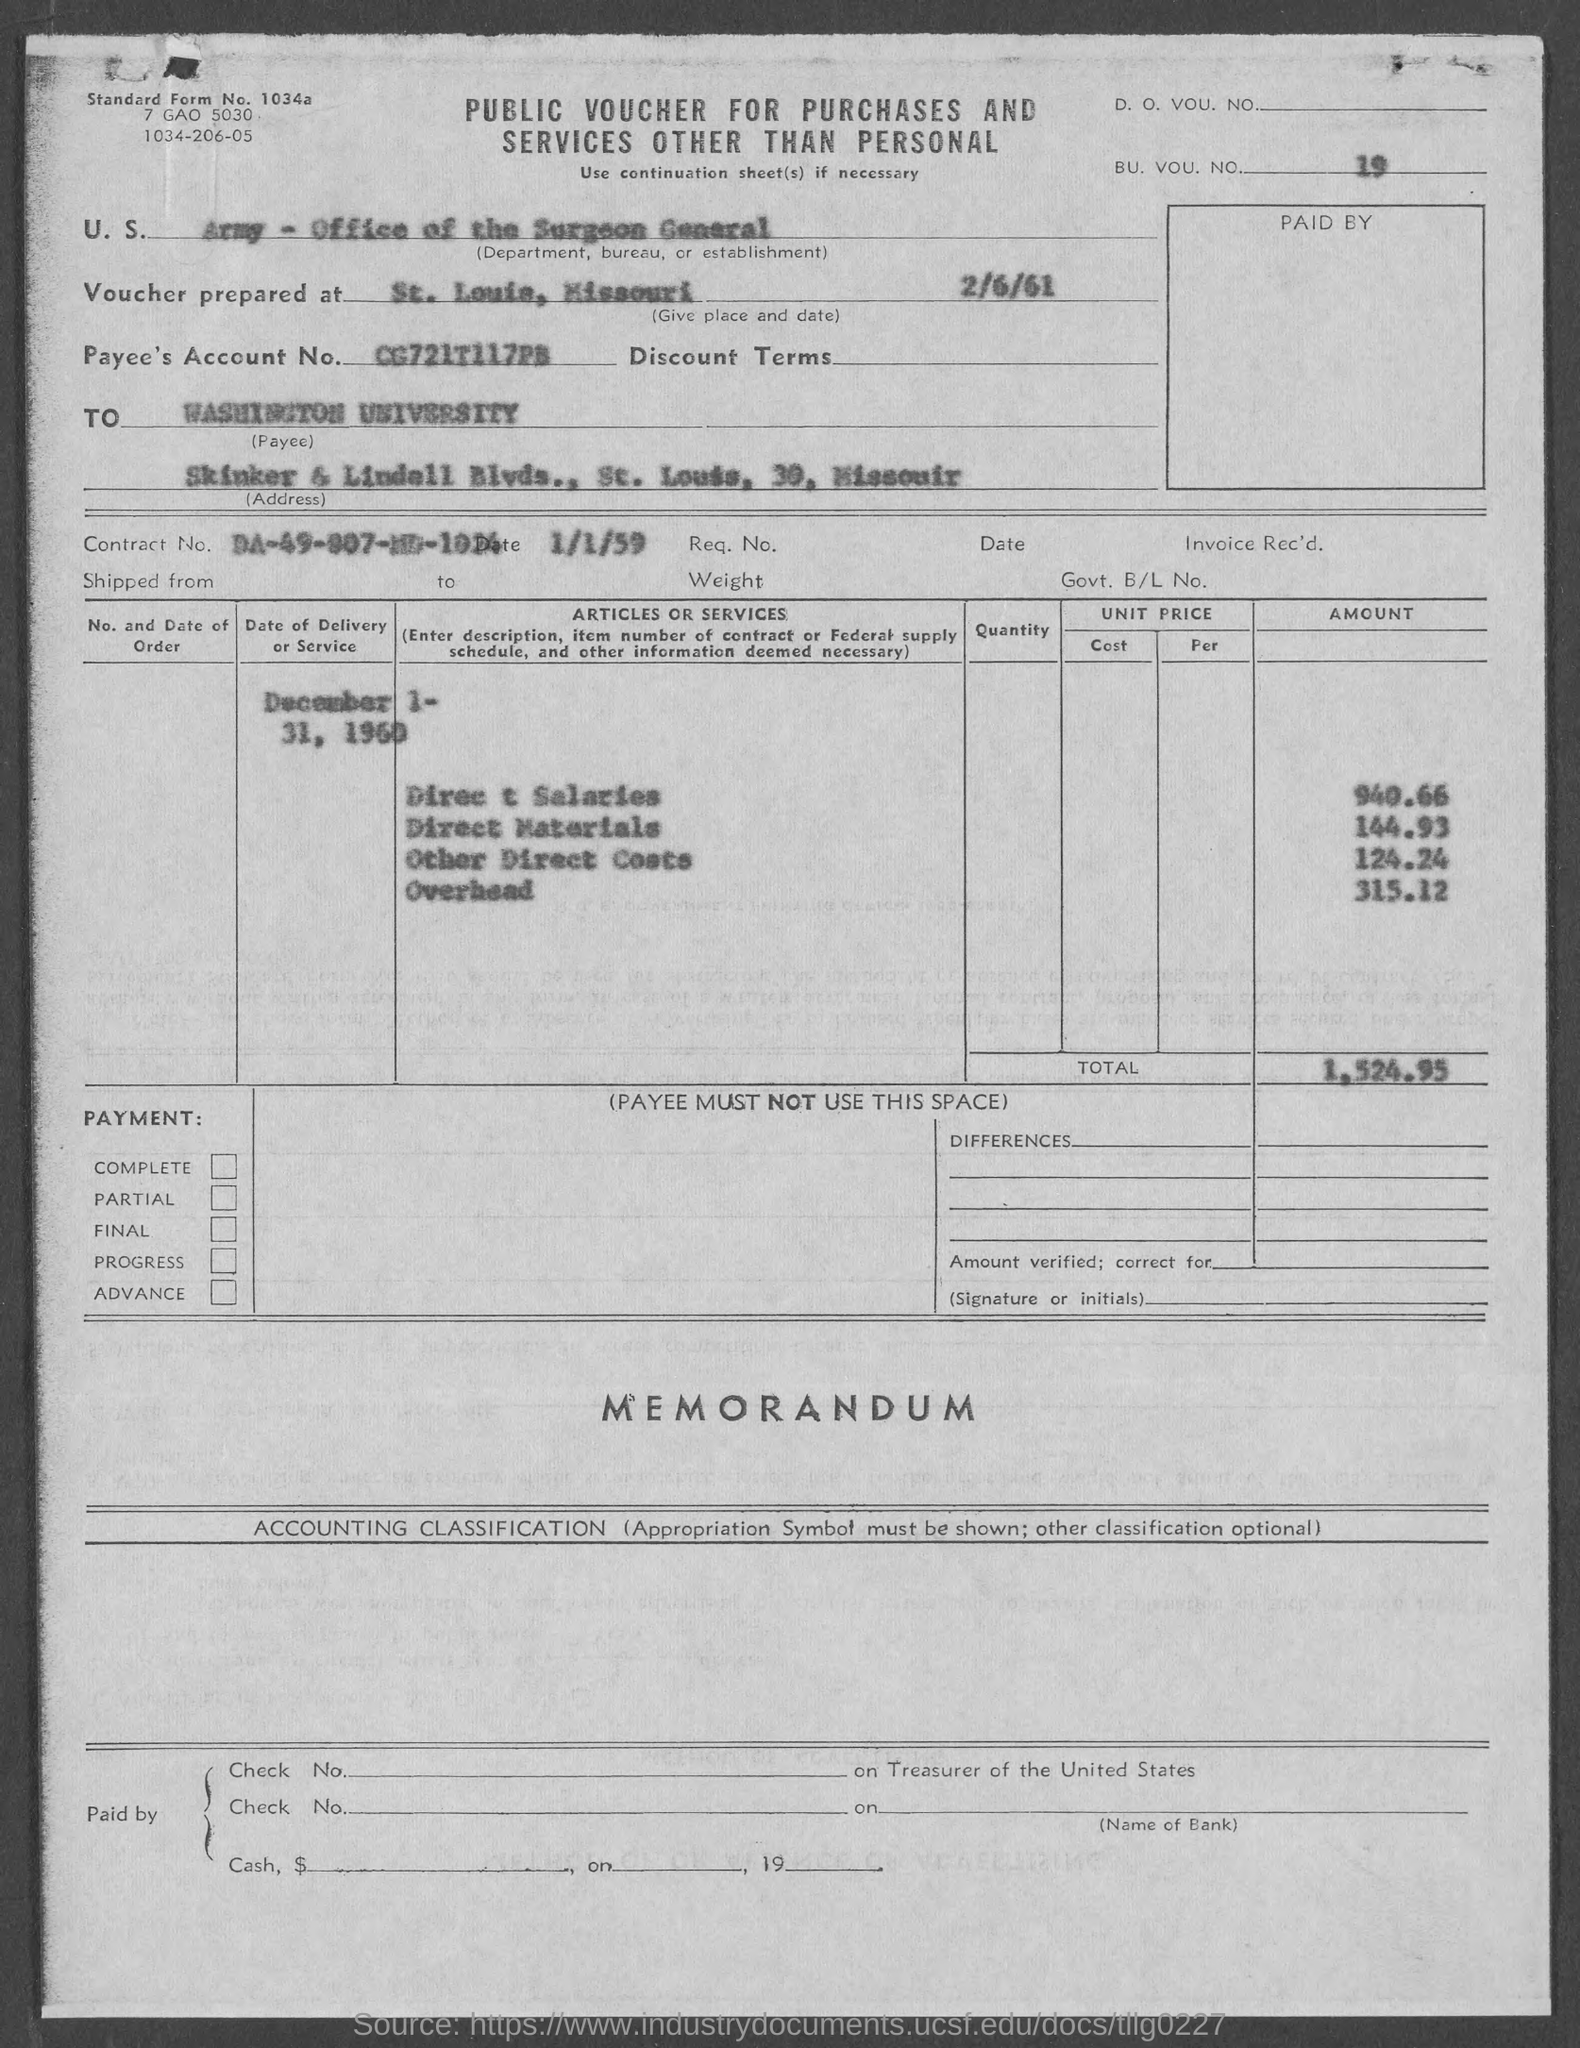What is the BU. VOU. NO?
Your answer should be compact. 19. The voucher is prepared at?
Your answer should be compact. St. Louis, Missouri. Who is the Payee?
Your response must be concise. Washington University. What is the Payee's Account No.?
Your response must be concise. CG721T117PB. 